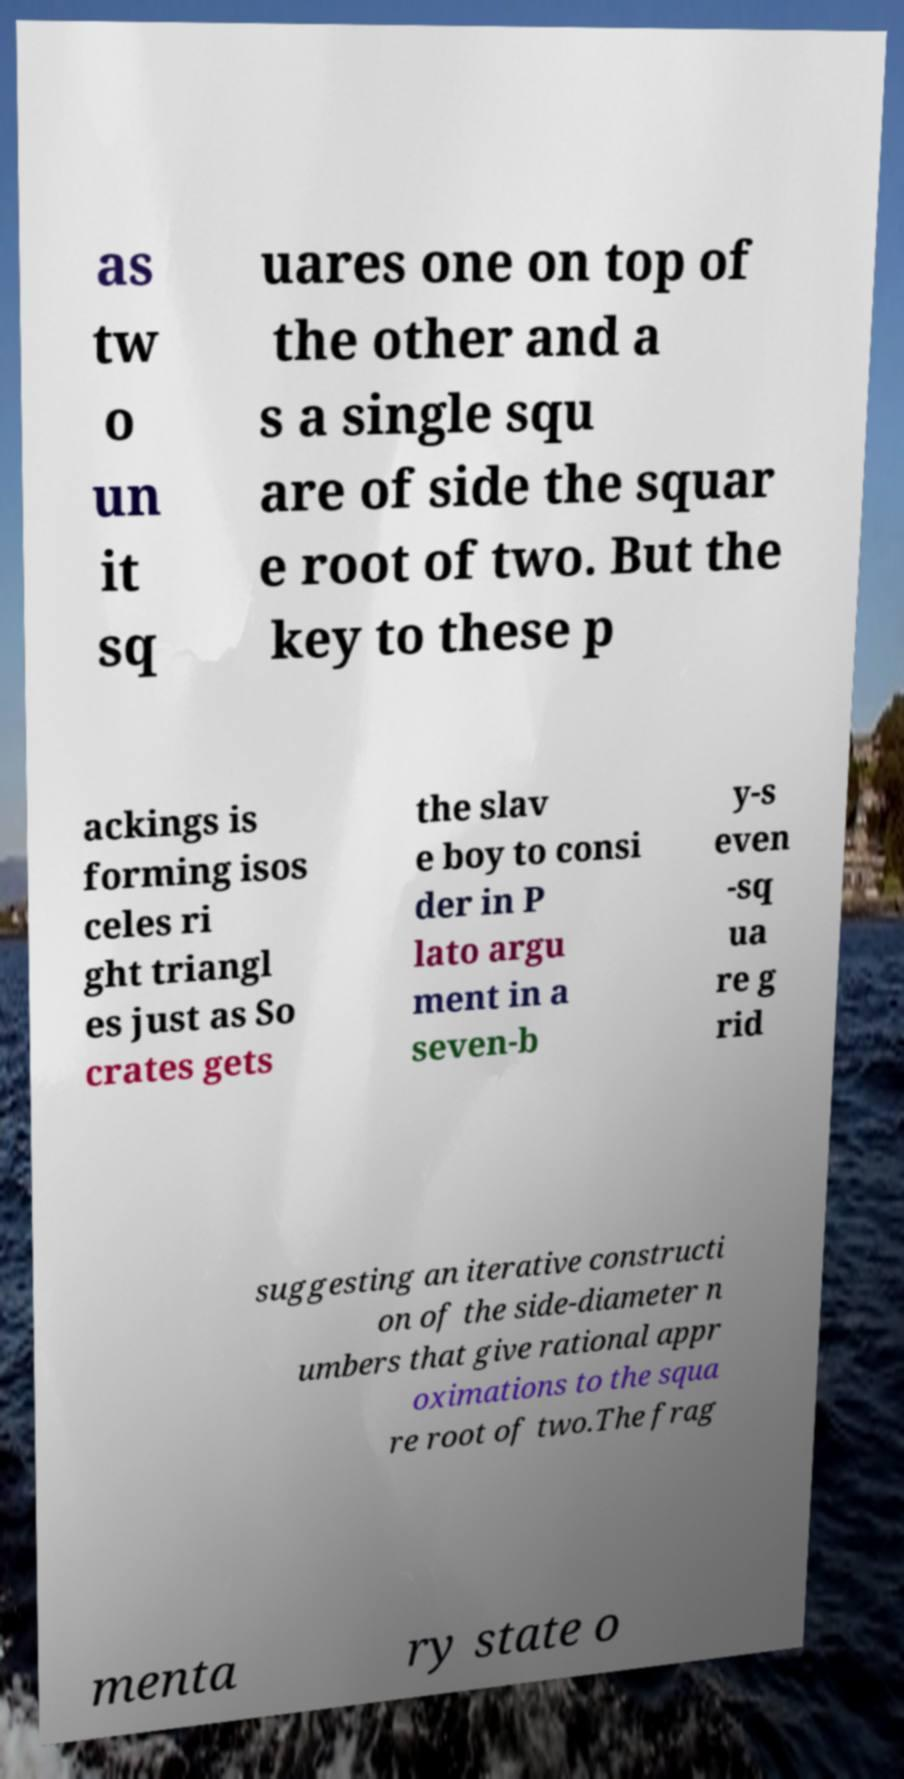Can you accurately transcribe the text from the provided image for me? as tw o un it sq uares one on top of the other and a s a single squ are of side the squar e root of two. But the key to these p ackings is forming isos celes ri ght triangl es just as So crates gets the slav e boy to consi der in P lato argu ment in a seven-b y-s even -sq ua re g rid suggesting an iterative constructi on of the side-diameter n umbers that give rational appr oximations to the squa re root of two.The frag menta ry state o 